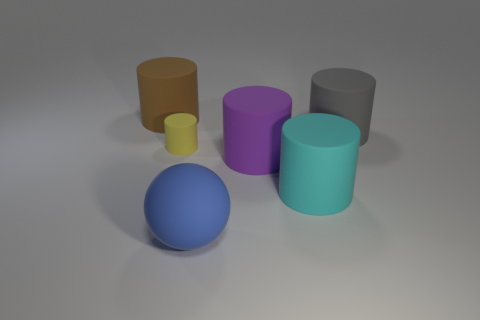The big object behind the thing that is to the right of the cylinder in front of the purple rubber thing is what shape? The large object located behind the object to the right of the cylinder, in front of the purple object, is also a cylinder. 